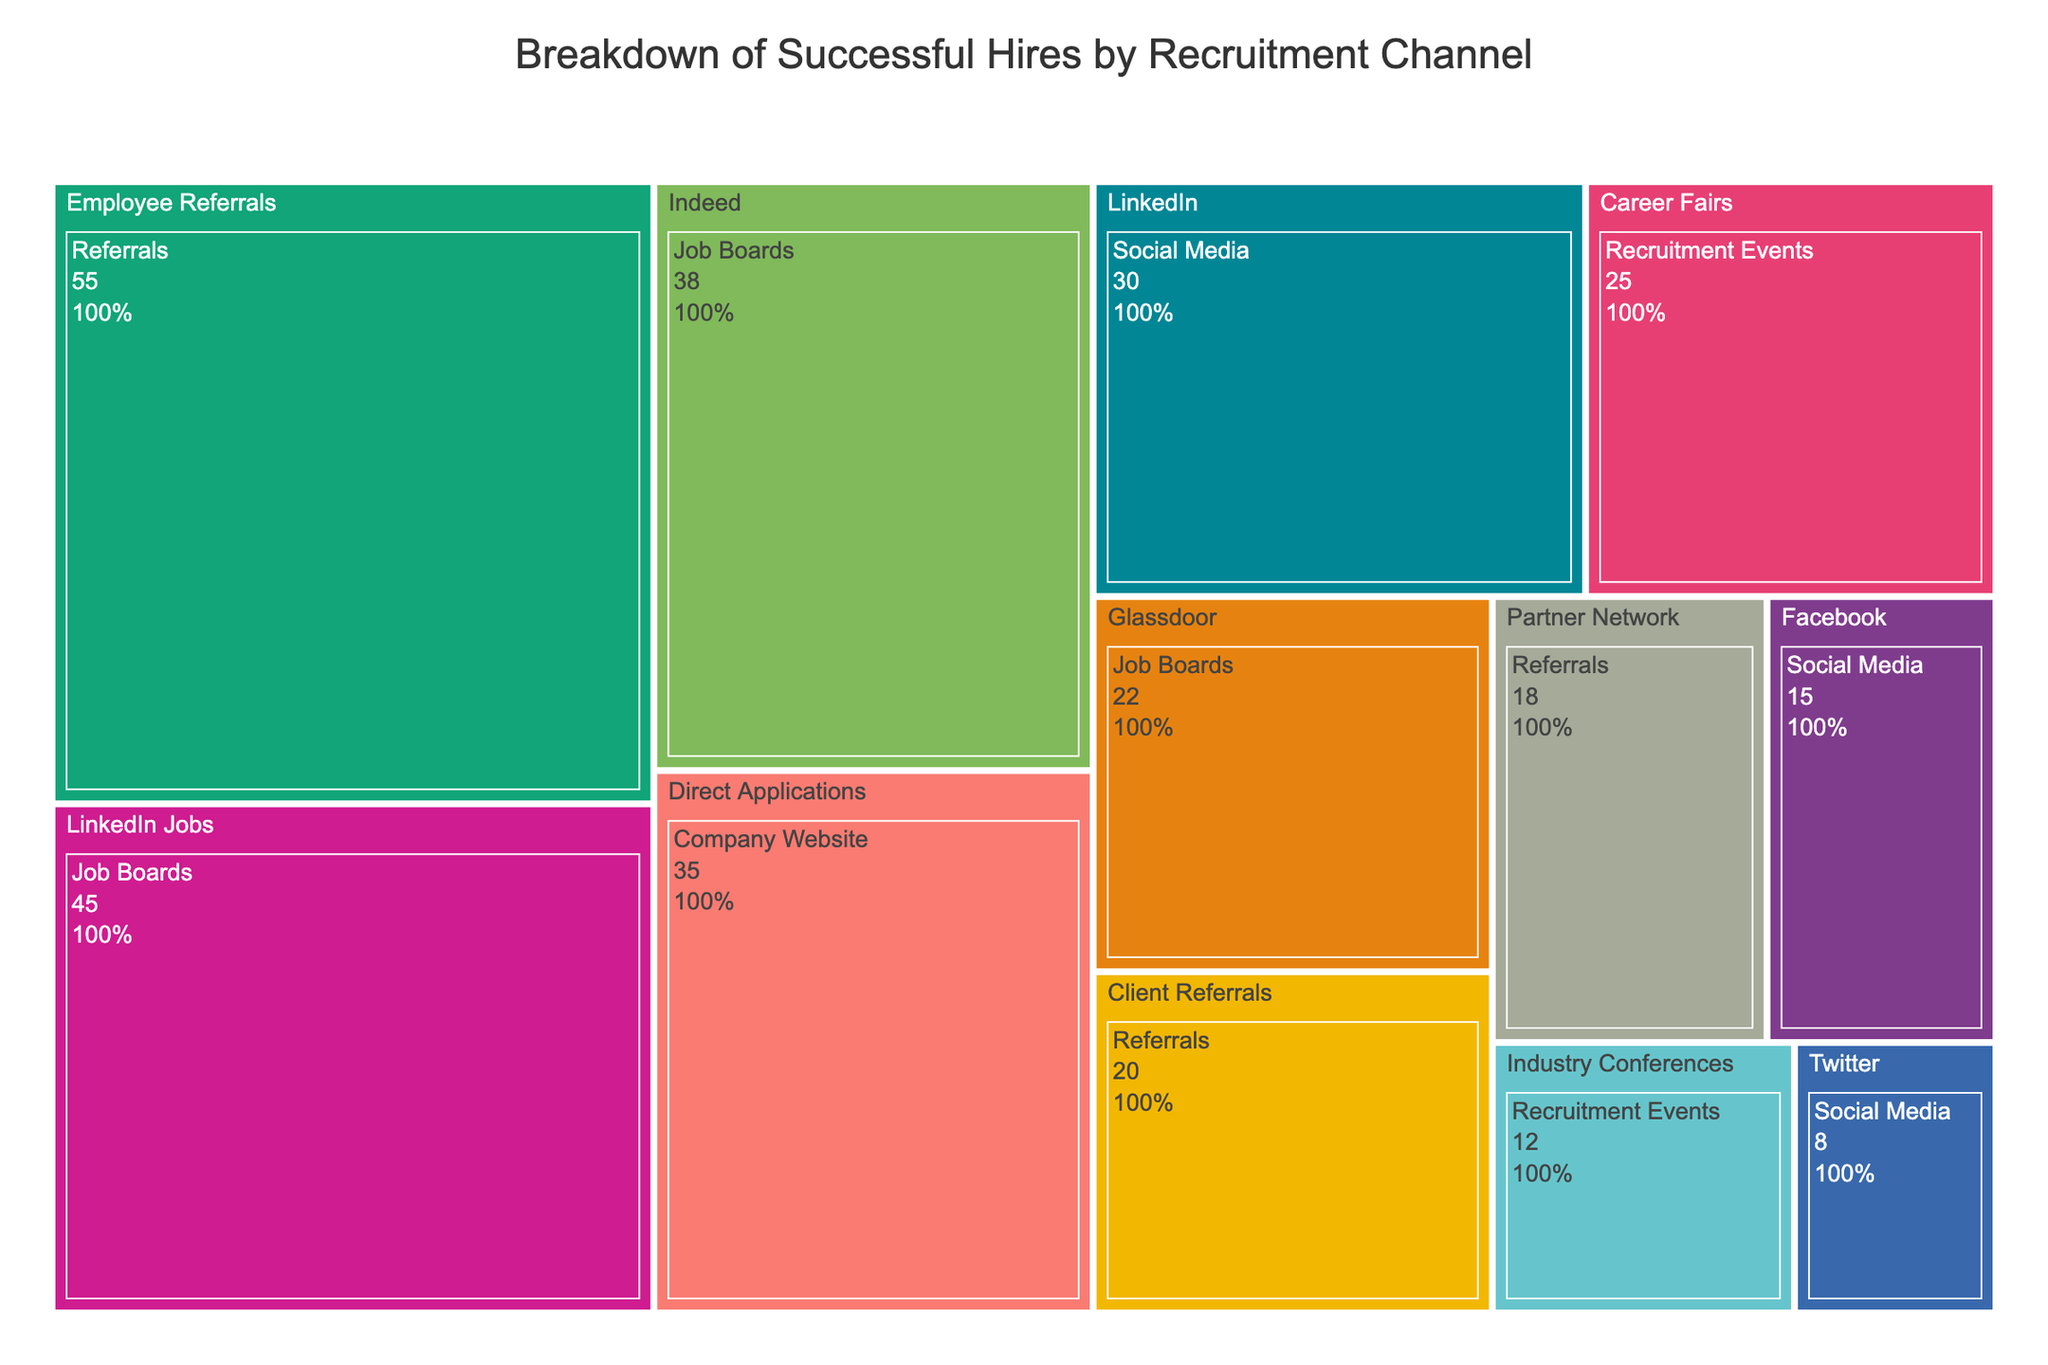What is the total number of successful hires from job boards? First, identify the channels under 'Job Boards' category: LinkedIn Jobs, Indeed, and Glassdoor. Sum their hires: 45 (LinkedIn Jobs) + 38 (Indeed) + 22 (Glassdoor) = 105.
Answer: 105 Which channel has the highest number of successful hires and how many does it have? Look for the channel with the highest value. 'Employee Referrals' under 'Referrals' has the highest value at 55 hires.
Answer: Employee Referrals, 55 Which recruitment channel has the fewest hires, and what is the number? Identify the lowest value visually in the treemap. 'Twitter' under 'Social Media' has the fewest hires at 8.
Answer: Twitter, 8 What is the combined total of successful hires from social media channels? Identify the channels under 'Social Media': LinkedIn, Facebook, and Twitter. Sum their hires: 30 (LinkedIn) + 15 (Facebook) + 8 (Twitter) = 53.
Answer: 53 How do successful hires from direct applications compare to those from LinkedIn jobs? Compare 'Direct Applications' hires (35) with 'LinkedIn Jobs' hires (45).
Answer: LinkedIn Jobs has more (45 compared to 35) Between recruitment events and company website, which has more hires and by how much? Total hires for 'Recruitment Events': 25 (Career Fairs) + 12 (Industry Conferences) = 37. Total hires for 'Company Website': 35 (Direct Applications). Difference: 37 - 35 = 2.
Answer: Recruitment Events by 2 Which category, 'Referrals' or 'Job Boards', contributes more to successful hires and what is the difference? Total hires for 'Referrals': 55 (Employee Referrals) + 20 (Client Referrals) + 18 (Partner Network) = 93. Total hires for 'Job Boards': 45 (LinkedIn Jobs) + 38 (Indeed) + 22 (Glassdoor) = 105. Difference: 105 - 93 = 12.
Answer: Job Boards by 12 What percentage of all successful hires come from employee referrals? Total hires = 105 (Job Boards) + 53 (Social Media) + 93 (Referrals) + 37 (Recruitment Events) + 35 (Company Website) = 323. Percentage for 'Employee Referrals' = (55 / 323) * 100 ≈ 17.0%.
Answer: 17.0% 